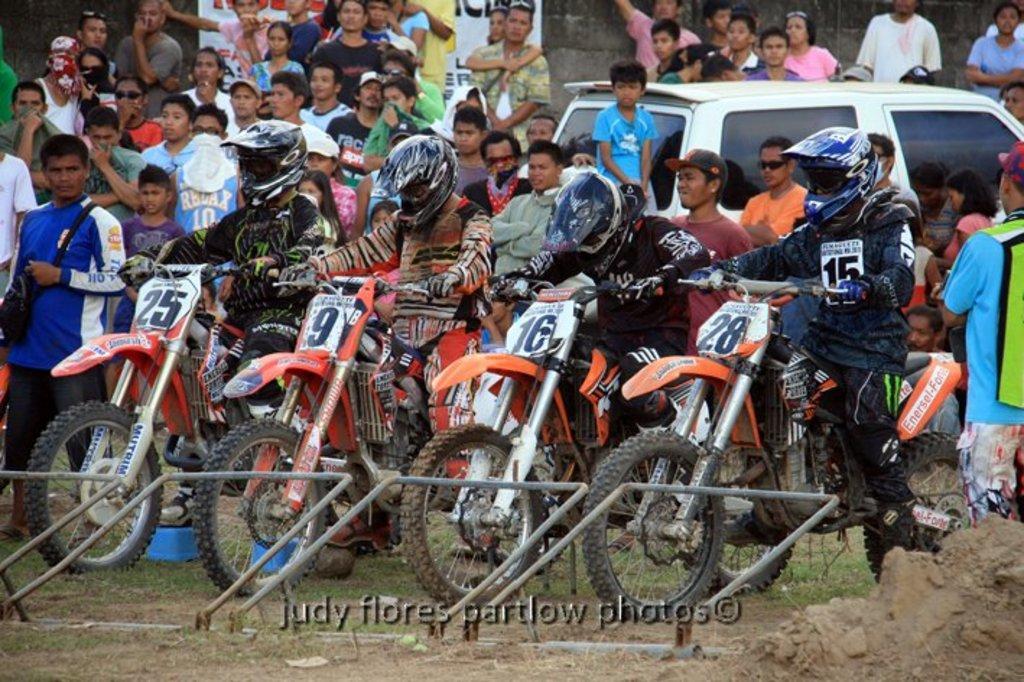How would you summarize this image in a sentence or two? In this picture I can see few people are standing and watching and I can see a car parked on the side and few motorcycles and few of them are seated and they wore helmets and I can see a watermark at the bottom of the picture and the picture looks like a motorcycle racing. 